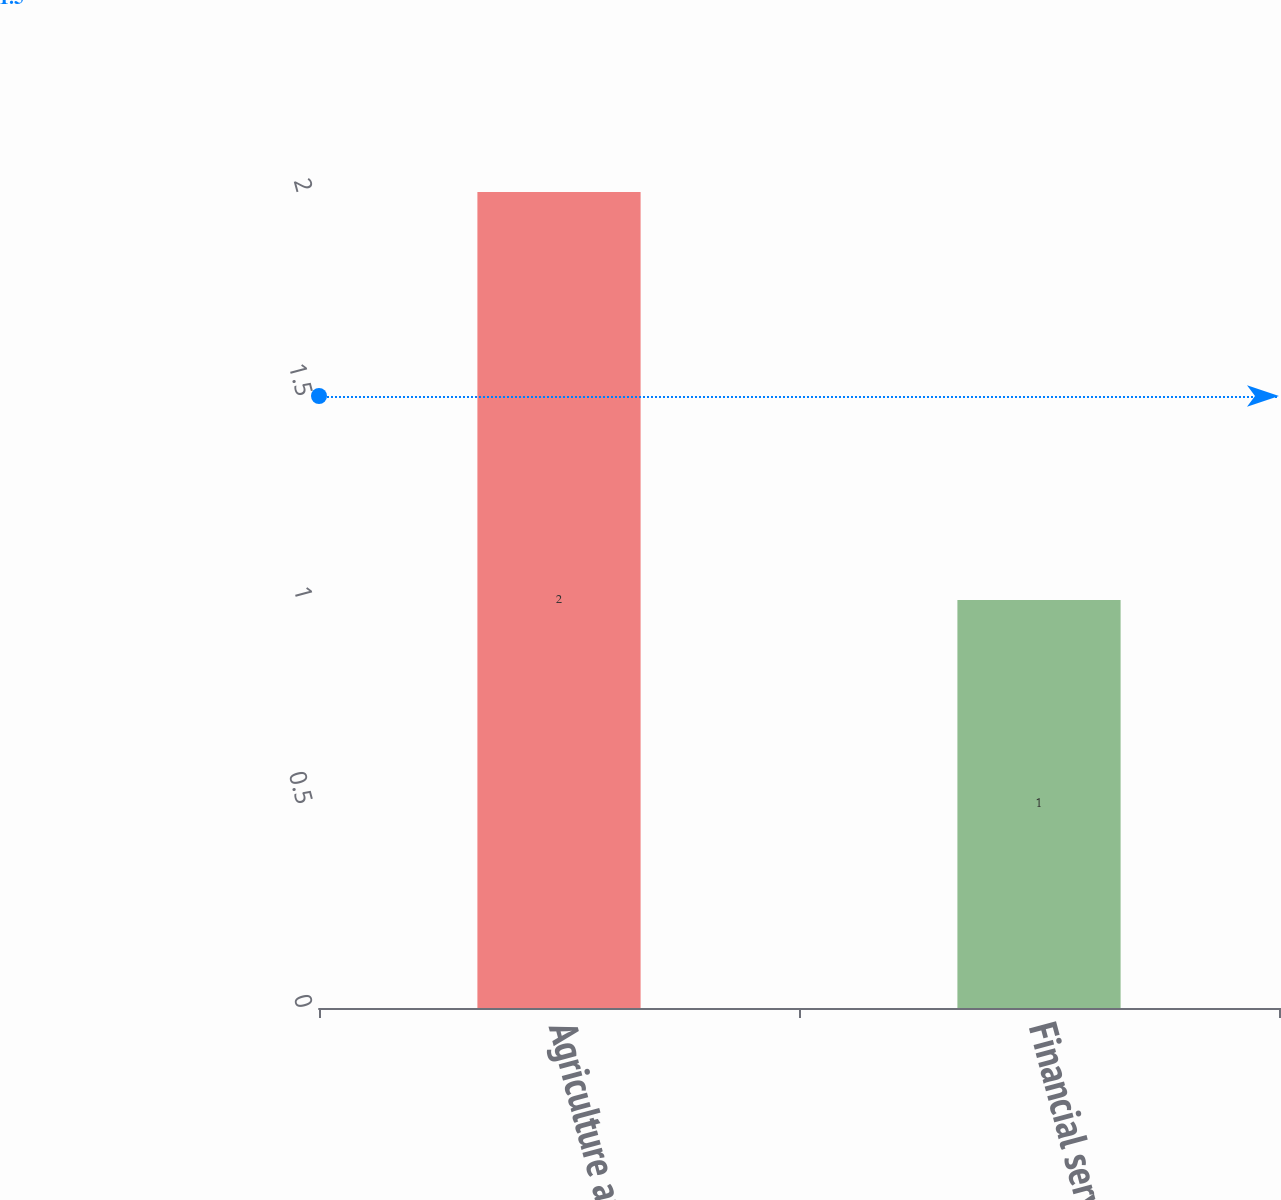Convert chart to OTSL. <chart><loc_0><loc_0><loc_500><loc_500><bar_chart><fcel>Agriculture and turf<fcel>Financial services<nl><fcel>2<fcel>1<nl></chart> 